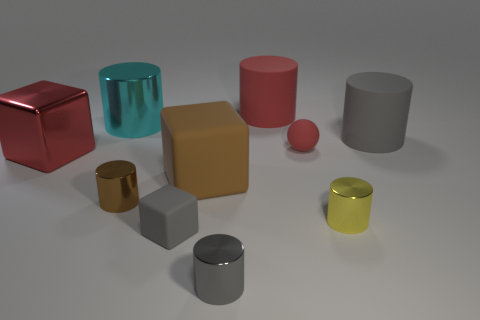Subtract 1 cylinders. How many cylinders are left? 5 Subtract all cyan cylinders. How many cylinders are left? 5 Subtract all gray rubber cylinders. How many cylinders are left? 5 Subtract all cyan cylinders. Subtract all brown balls. How many cylinders are left? 5 Subtract all cylinders. How many objects are left? 4 Add 8 big cyan metal cylinders. How many big cyan metal cylinders exist? 9 Subtract 0 brown spheres. How many objects are left? 10 Subtract all red blocks. Subtract all big brown cubes. How many objects are left? 8 Add 3 big gray rubber cylinders. How many big gray rubber cylinders are left? 4 